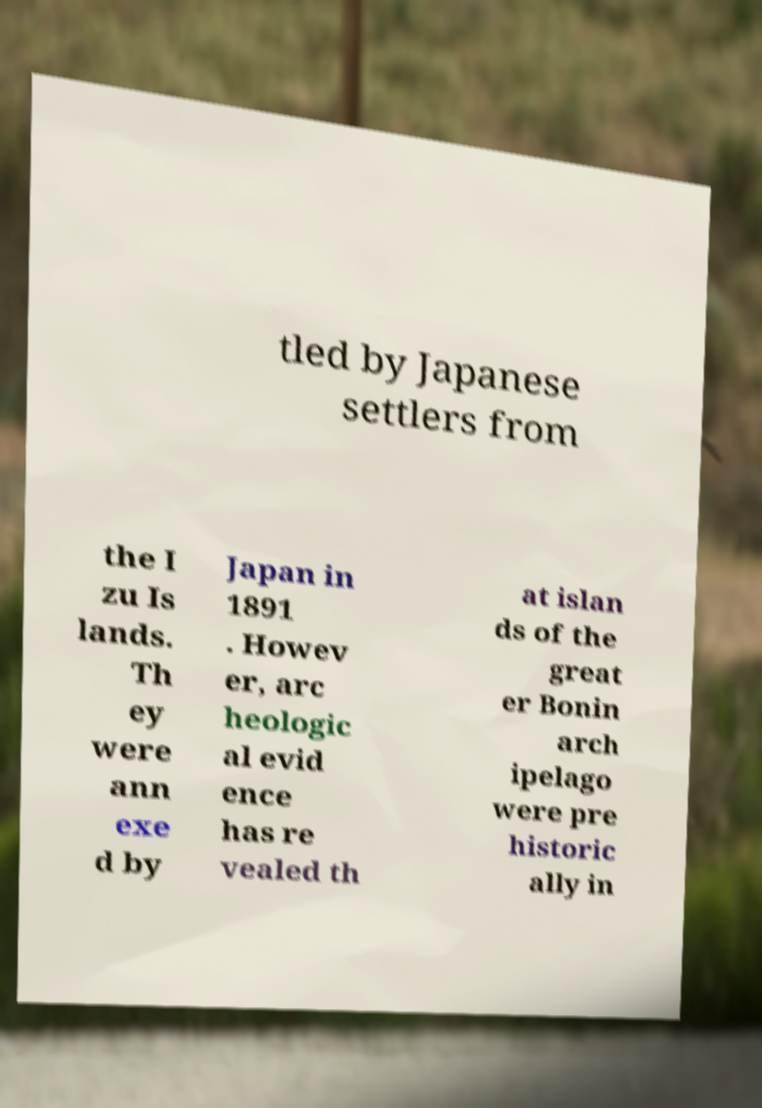Can you accurately transcribe the text from the provided image for me? tled by Japanese settlers from the I zu Is lands. Th ey were ann exe d by Japan in 1891 . Howev er, arc heologic al evid ence has re vealed th at islan ds of the great er Bonin arch ipelago were pre historic ally in 